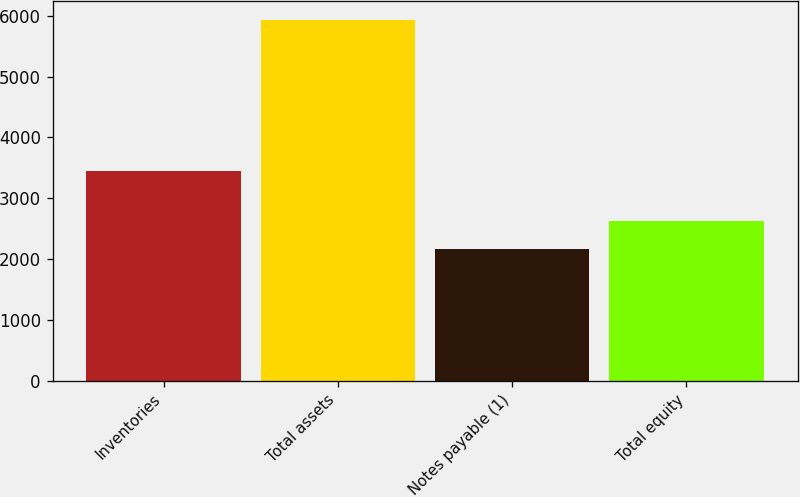<chart> <loc_0><loc_0><loc_500><loc_500><bar_chart><fcel>Inventories<fcel>Total assets<fcel>Notes payable (1)<fcel>Total equity<nl><fcel>3449<fcel>5938.6<fcel>2171.8<fcel>2622.9<nl></chart> 